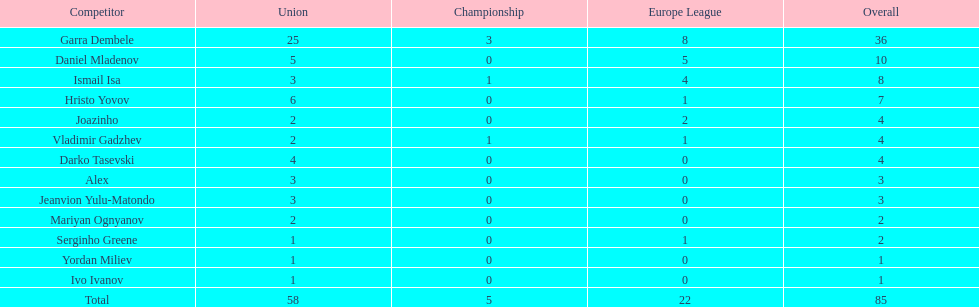How many players did not score a goal in cup play? 10. 